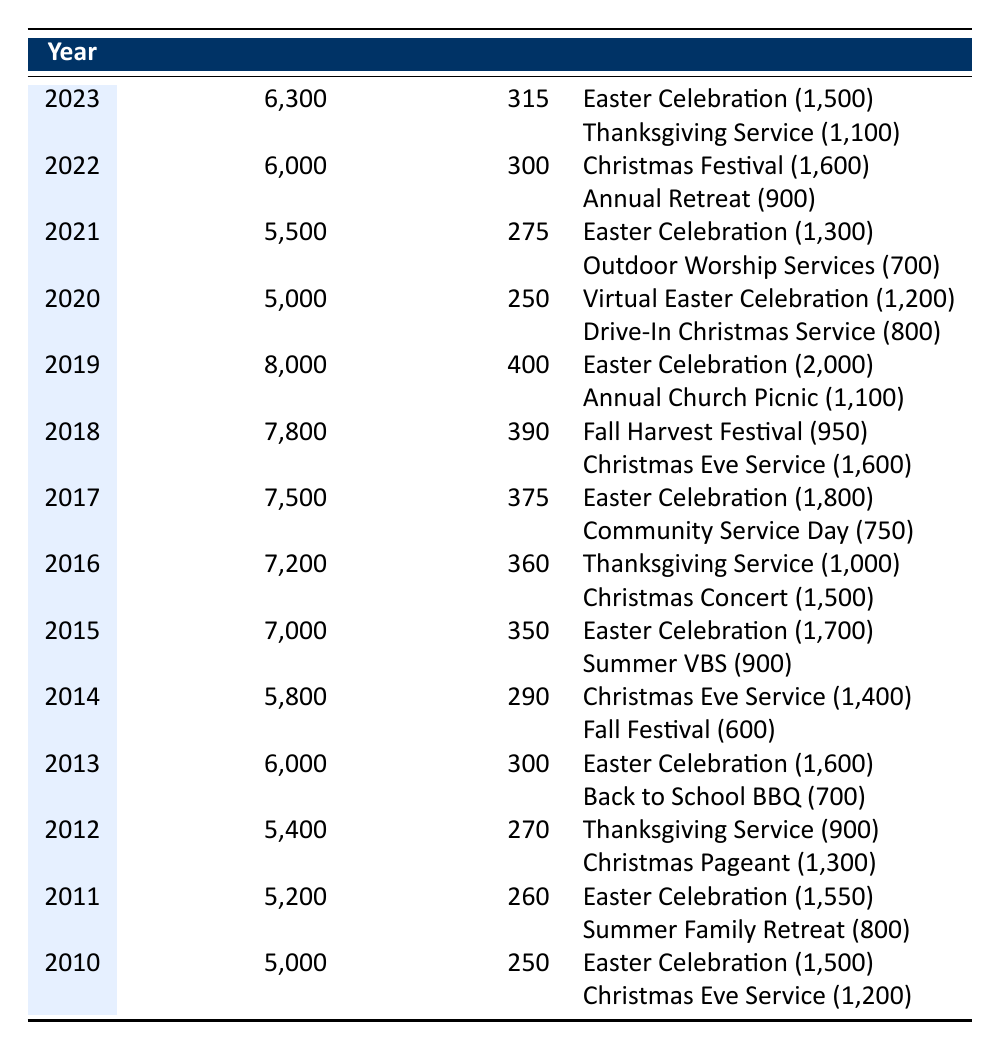What was the total attendance in 2018? The table shows that in 2018, the total attendance was listed as 7,800.
Answer: 7,800 Which year had the highest average attendance per service? By examining the average attendance per service column, the highest value is seen in 2019, which is 400.
Answer: 2019 What were the special events in 2021 and their attendances? The special events in 2021 were the Easter Celebration with an attendance of 1,300 and the Outdoor Worship Services with 700 attendees.
Answer: Easter Celebration (1,300), Outdoor Worship Services (700) What is the difference in total attendance between 2015 and 2020? The total attendance for 2015 is 7,000 and for 2020 is 5,000. The difference is calculated as 7,000 - 5,000 = 2,000.
Answer: 2,000 Did the attendance in 2014 exceed the attendance in 2012? In 2014, the attendance was 5,800, while in 2012 it was 5,400. Since 5,800 is greater than 5,400, the answer is yes.
Answer: Yes How many special events had an attendance of over 1,600 in the years provided? By inspecting the special events, we see that Easter Celebrations in 2017 (1,800), 2018 (2,000), and 2019 (2,000), and Christmas Concert in 2016 (1,500) do not exceed 1,600. Therefore, the final count of events is 4 (from different years).
Answer: 4 What is the average total attendance from 2010 to 2023? The total attendance for each year is summed up (5,000 + 5,200 + 5,400 + 6,000 + 5,800 + 7,000 + 7,200 + 7,500 + 7,800 + 8,000 + 5,000 + 5,500 + 6,000 + 6,300) = 88,200 and then divided by 14 (the number of years) gives an average attendance of approximately 6,300.
Answer: 6,300 Which year saw a decrease in attendance from the previous year? Looking through the annual total attendance records, 2020's attendance of 5,000 is lower than 2019's attendance of 8,000, indicating a decrease.
Answer: 2020 Was the Easter Celebration consistently attended each year from 2010 to 2023? By checking the attendance numbers for the Easter Celebrations each year, they were present every year but varied in attendance, indicating that while it occurred, attendance was not consistent.
Answer: No 